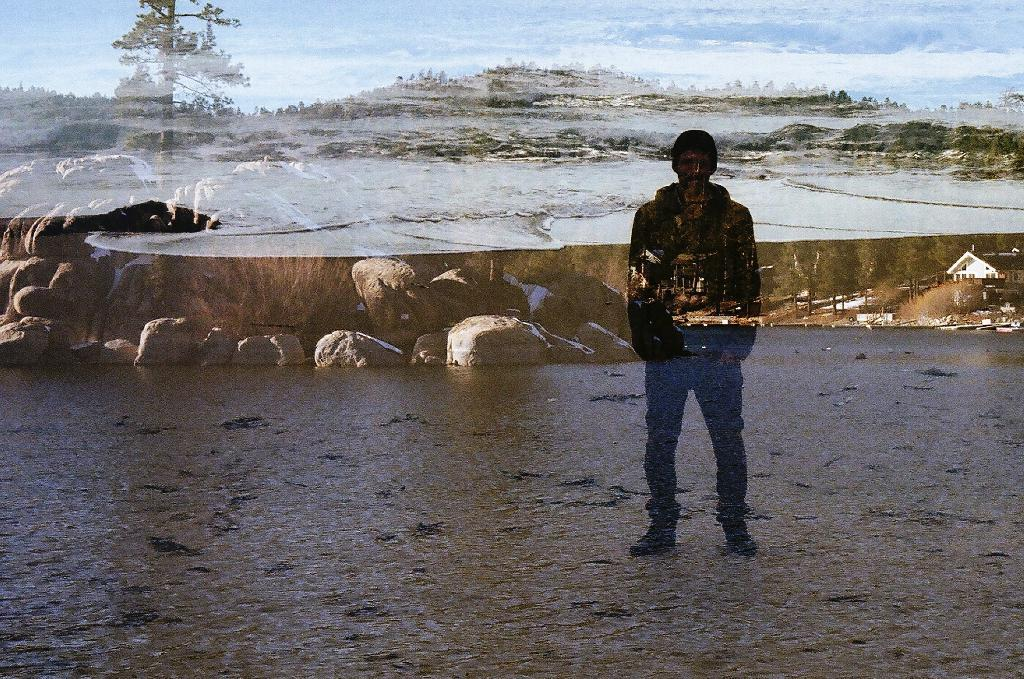What is the main subject in the image? There is a person standing in the image. What structure is located on the right side of the image? There is a house on the right side of the image. What type of vegetation is at the top of the image? There are trees at the top of the image. What is visible at the top of the image besides the trees? The sky is visible at the top of the image. What type of string is being used to create the design on the person's shirt in the image? There is no string or design on the person's shirt visible in the image. Can you tell me how many cows are grazing in the background of the image? There are no cows present in the image; it features a person, a house, trees, and the sky. 